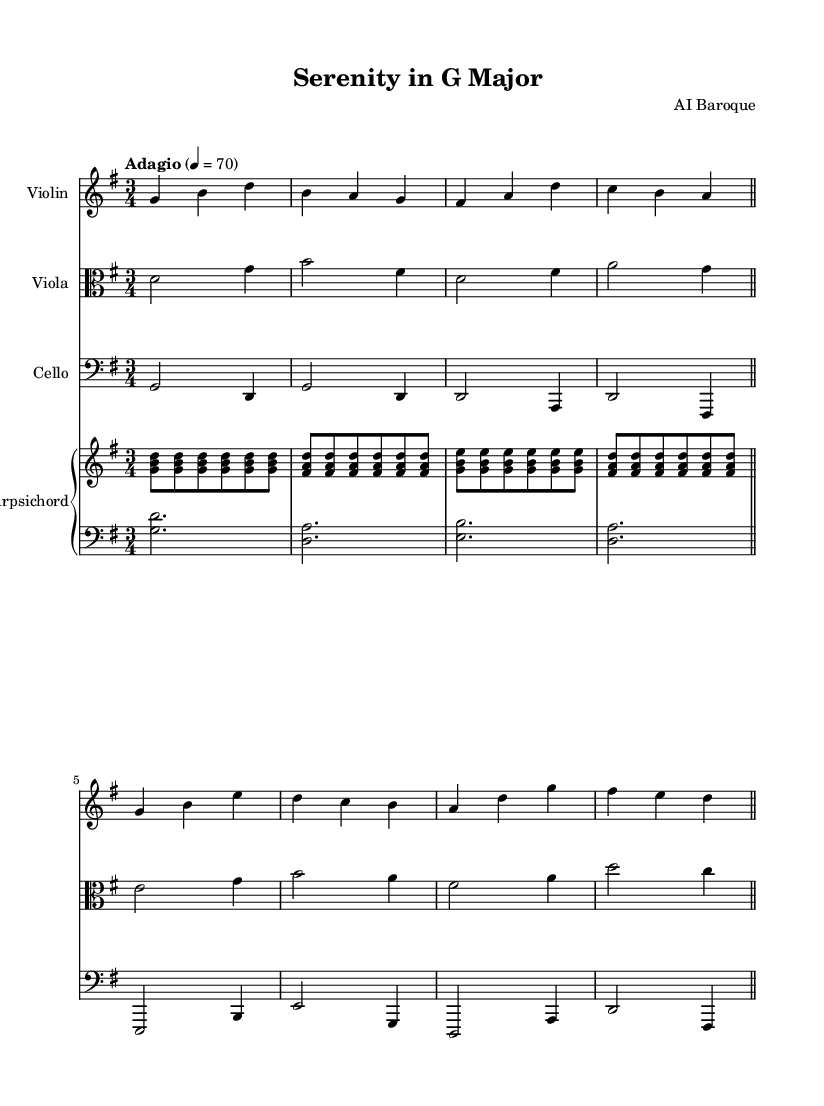What is the key signature of this music? The key signature indicated is G major, which has one sharp (F#). This can be identified by looking at the key signature drawn on the staff at the beginning of the music, showing one sharp.
Answer: G major What is the time signature of this music? The time signature shown is 3/4, which means there are three beats in each measure and the quarter note gets one beat. This is observed in the fraction-like symbol at the beginning of the music.
Answer: 3/4 What is the tempo marking for this piece? The tempo marking states "Adagio," which means a slow tempo, typically around 66-76 beats per minute. This is indicated by the word "Adagio" written in the tempo indication section.
Answer: Adagio How many instruments are involved in this piece? There are four distinct instrumental parts indicated: Violin, Viola, Cello, and Harpsichord. This is confirmed by the presence of separate staves labeled for each instrument at the start of their respective sections.
Answer: Four Which instrument has the highest pitch in this piece? The Violin plays the highest notes in the score, as it is notated in the highest staff position and plays the upper melody lines. Comparing the staves visually reveals that the Violin's notes are higher than those of the Viola and Cello.
Answer: Violin What is the harmonic role of the Harpsichord in this music? The Harpsichord functions as the harmonic support, providing chords underneath the melodic lines played by the strings. This is evidenced by its two separate staves, with one playing chords (left hand) and the other playing a counterpart (right hand) above the bass.
Answer: Harmonic support What type of musical texture is primarily used in this piece? The music primarily exhibits a homophonic texture, meaning one main melody is accompanied by chords, which is typical in chamber music of the Baroque period. This can be inferred from the relationship of the vocal lines in the instruments and the chordal background from the Harpsichord.
Answer: Homophonic 